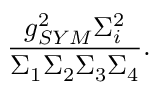Convert formula to latex. <formula><loc_0><loc_0><loc_500><loc_500>\frac { g _ { S Y M } ^ { 2 } \Sigma _ { i } ^ { 2 } } { \Sigma _ { 1 } \Sigma _ { 2 } \Sigma _ { 3 } \Sigma _ { 4 } } .</formula> 